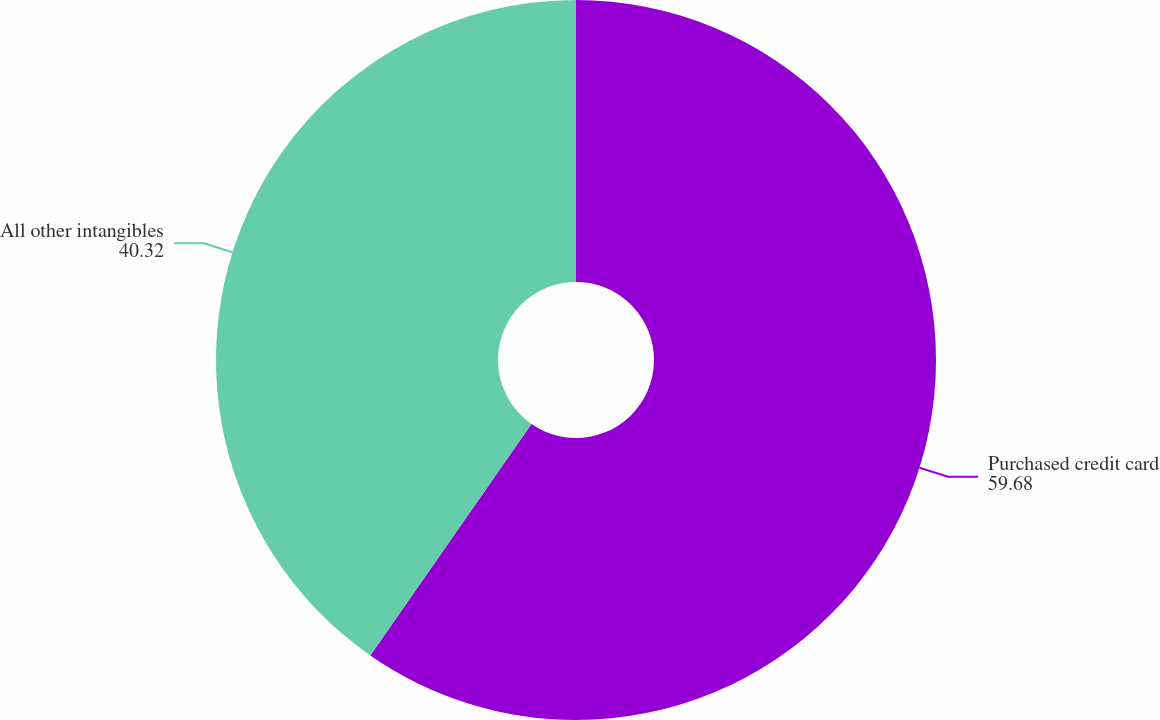Convert chart. <chart><loc_0><loc_0><loc_500><loc_500><pie_chart><fcel>Purchased credit card<fcel>All other intangibles<nl><fcel>59.68%<fcel>40.32%<nl></chart> 